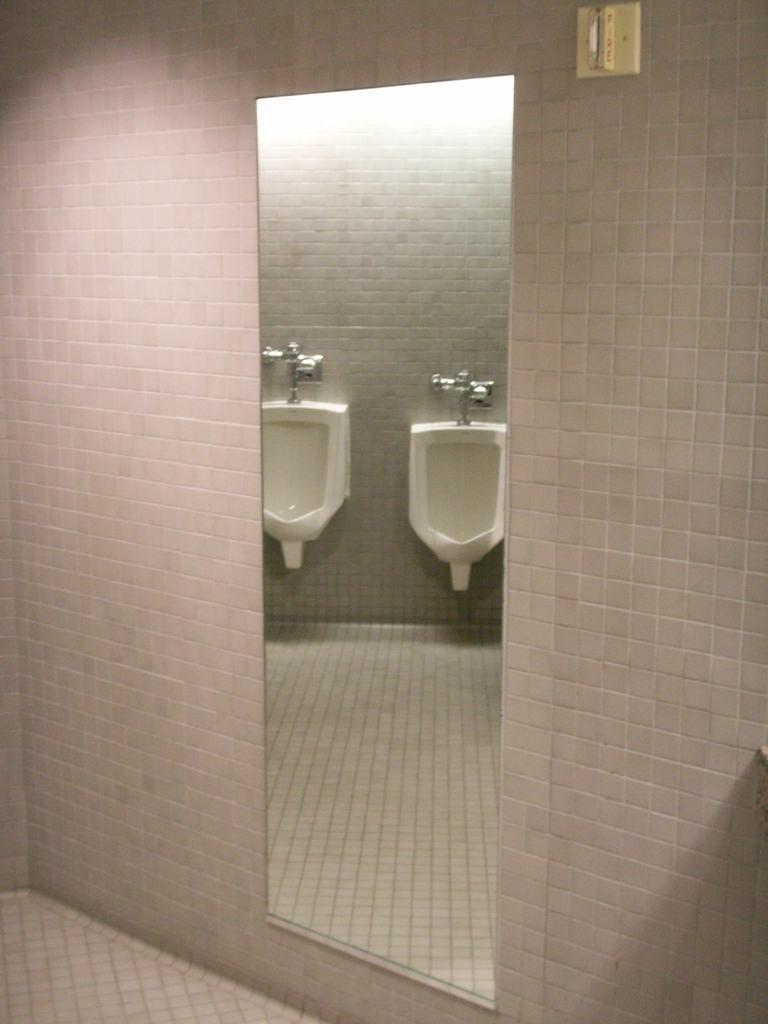What is present on the wall in the image? There is a mirror on the wall in the image. What does the mirror reflect in the image? The mirror reflects toilets in the image. What type of railway can be seen in the image? There is no railway present in the image. What is the interest rate of the loan mentioned in the image? There is no mention of a loan or interest rate in the image. 